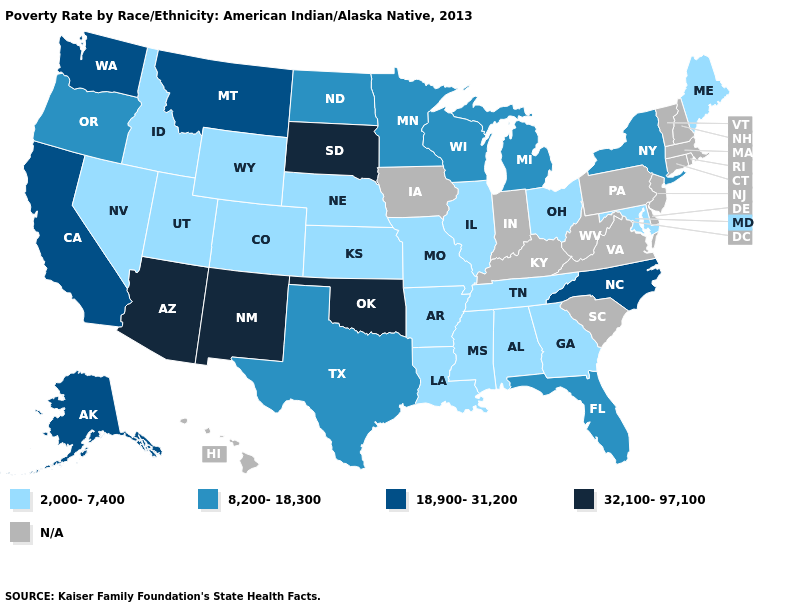Which states have the lowest value in the West?
Keep it brief. Colorado, Idaho, Nevada, Utah, Wyoming. Does Maine have the highest value in the USA?
Be succinct. No. Name the states that have a value in the range N/A?
Keep it brief. Connecticut, Delaware, Hawaii, Indiana, Iowa, Kentucky, Massachusetts, New Hampshire, New Jersey, Pennsylvania, Rhode Island, South Carolina, Vermont, Virginia, West Virginia. Which states have the lowest value in the Northeast?
Short answer required. Maine. Name the states that have a value in the range N/A?
Short answer required. Connecticut, Delaware, Hawaii, Indiana, Iowa, Kentucky, Massachusetts, New Hampshire, New Jersey, Pennsylvania, Rhode Island, South Carolina, Vermont, Virginia, West Virginia. What is the value of Florida?
Quick response, please. 8,200-18,300. What is the highest value in states that border New Jersey?
Short answer required. 8,200-18,300. Does Arizona have the highest value in the USA?
Be succinct. Yes. Among the states that border Wisconsin , which have the highest value?
Write a very short answer. Michigan, Minnesota. What is the lowest value in the USA?
Be succinct. 2,000-7,400. Name the states that have a value in the range 32,100-97,100?
Write a very short answer. Arizona, New Mexico, Oklahoma, South Dakota. Name the states that have a value in the range 32,100-97,100?
Give a very brief answer. Arizona, New Mexico, Oklahoma, South Dakota. What is the value of North Carolina?
Write a very short answer. 18,900-31,200. What is the value of Oklahoma?
Answer briefly. 32,100-97,100. 